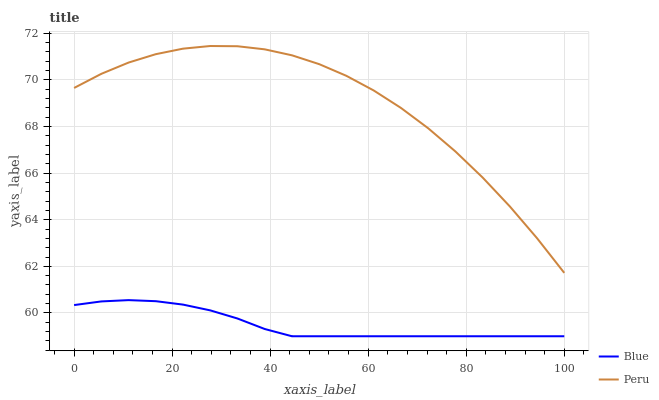Does Blue have the minimum area under the curve?
Answer yes or no. Yes. Does Peru have the maximum area under the curve?
Answer yes or no. Yes. Does Peru have the minimum area under the curve?
Answer yes or no. No. Is Blue the smoothest?
Answer yes or no. Yes. Is Peru the roughest?
Answer yes or no. Yes. Is Peru the smoothest?
Answer yes or no. No. Does Blue have the lowest value?
Answer yes or no. Yes. Does Peru have the lowest value?
Answer yes or no. No. Does Peru have the highest value?
Answer yes or no. Yes. Is Blue less than Peru?
Answer yes or no. Yes. Is Peru greater than Blue?
Answer yes or no. Yes. Does Blue intersect Peru?
Answer yes or no. No. 